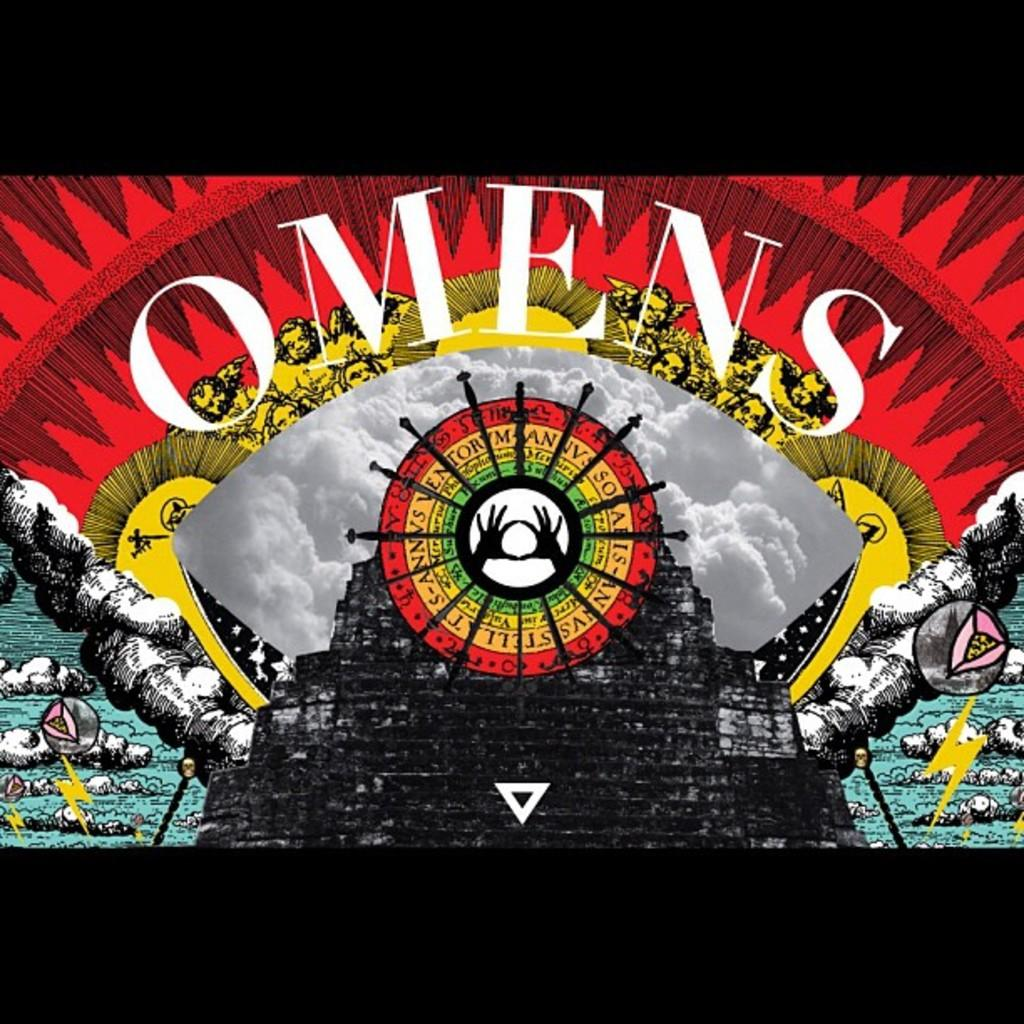<image>
Summarize the visual content of the image. A surreal piece of art with many different elements such as clouds and faces with the word omens printed on it. 